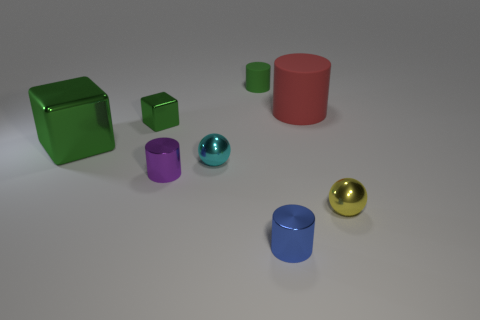Add 1 cyan spheres. How many objects exist? 9 Subtract all small blue metal cylinders. How many cylinders are left? 3 Subtract all red cylinders. How many cylinders are left? 3 Add 2 tiny yellow spheres. How many tiny yellow spheres are left? 3 Add 1 yellow metallic objects. How many yellow metallic objects exist? 2 Subtract 0 yellow cylinders. How many objects are left? 8 Subtract all balls. How many objects are left? 6 Subtract 1 blocks. How many blocks are left? 1 Subtract all blue cylinders. Subtract all purple cubes. How many cylinders are left? 3 Subtract all yellow objects. Subtract all red cylinders. How many objects are left? 6 